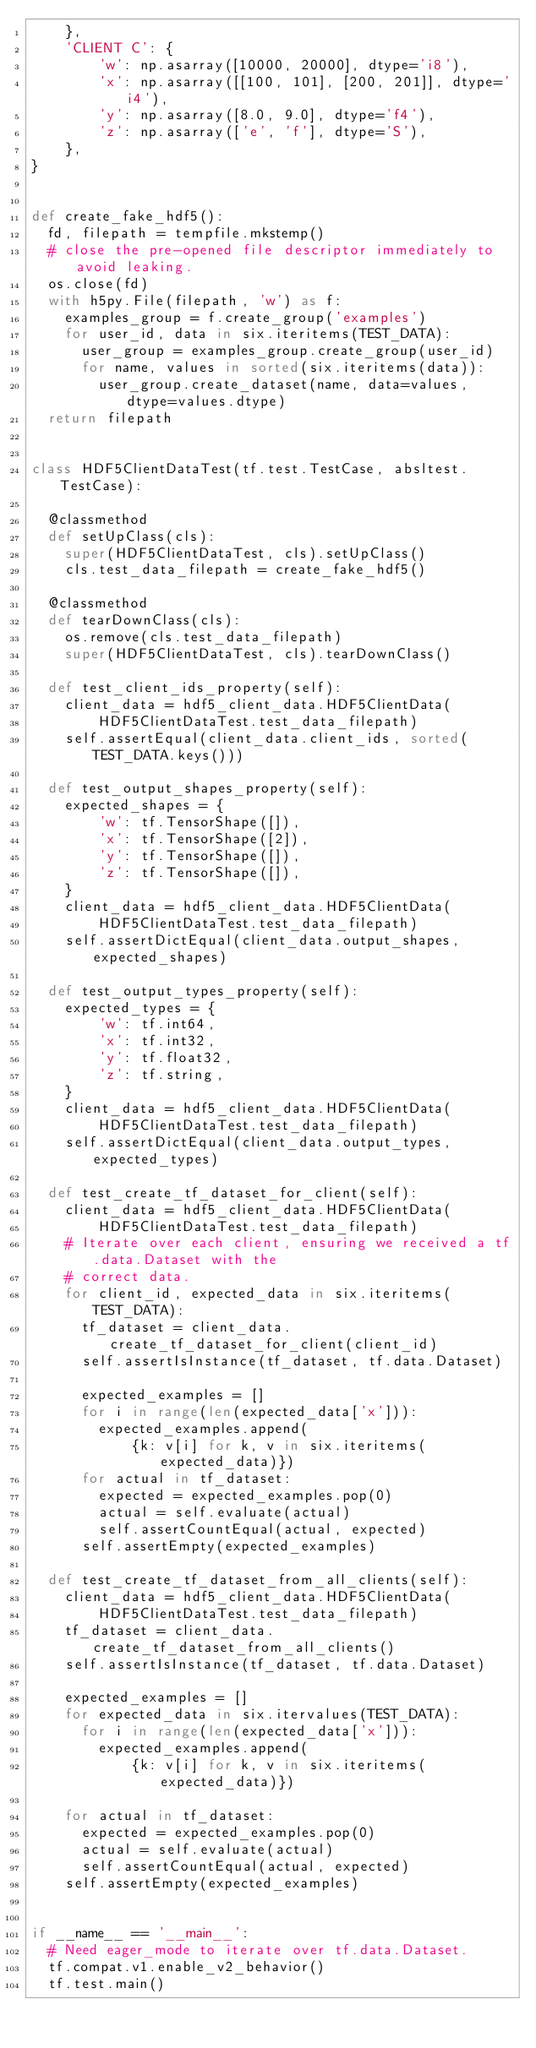<code> <loc_0><loc_0><loc_500><loc_500><_Python_>    },
    'CLIENT C': {
        'w': np.asarray([10000, 20000], dtype='i8'),
        'x': np.asarray([[100, 101], [200, 201]], dtype='i4'),
        'y': np.asarray([8.0, 9.0], dtype='f4'),
        'z': np.asarray(['e', 'f'], dtype='S'),
    },
}


def create_fake_hdf5():
  fd, filepath = tempfile.mkstemp()
  # close the pre-opened file descriptor immediately to avoid leaking.
  os.close(fd)
  with h5py.File(filepath, 'w') as f:
    examples_group = f.create_group('examples')
    for user_id, data in six.iteritems(TEST_DATA):
      user_group = examples_group.create_group(user_id)
      for name, values in sorted(six.iteritems(data)):
        user_group.create_dataset(name, data=values, dtype=values.dtype)
  return filepath


class HDF5ClientDataTest(tf.test.TestCase, absltest.TestCase):

  @classmethod
  def setUpClass(cls):
    super(HDF5ClientDataTest, cls).setUpClass()
    cls.test_data_filepath = create_fake_hdf5()

  @classmethod
  def tearDownClass(cls):
    os.remove(cls.test_data_filepath)
    super(HDF5ClientDataTest, cls).tearDownClass()

  def test_client_ids_property(self):
    client_data = hdf5_client_data.HDF5ClientData(
        HDF5ClientDataTest.test_data_filepath)
    self.assertEqual(client_data.client_ids, sorted(TEST_DATA.keys()))

  def test_output_shapes_property(self):
    expected_shapes = {
        'w': tf.TensorShape([]),
        'x': tf.TensorShape([2]),
        'y': tf.TensorShape([]),
        'z': tf.TensorShape([]),
    }
    client_data = hdf5_client_data.HDF5ClientData(
        HDF5ClientDataTest.test_data_filepath)
    self.assertDictEqual(client_data.output_shapes, expected_shapes)

  def test_output_types_property(self):
    expected_types = {
        'w': tf.int64,
        'x': tf.int32,
        'y': tf.float32,
        'z': tf.string,
    }
    client_data = hdf5_client_data.HDF5ClientData(
        HDF5ClientDataTest.test_data_filepath)
    self.assertDictEqual(client_data.output_types, expected_types)

  def test_create_tf_dataset_for_client(self):
    client_data = hdf5_client_data.HDF5ClientData(
        HDF5ClientDataTest.test_data_filepath)
    # Iterate over each client, ensuring we received a tf.data.Dataset with the
    # correct data.
    for client_id, expected_data in six.iteritems(TEST_DATA):
      tf_dataset = client_data.create_tf_dataset_for_client(client_id)
      self.assertIsInstance(tf_dataset, tf.data.Dataset)

      expected_examples = []
      for i in range(len(expected_data['x'])):
        expected_examples.append(
            {k: v[i] for k, v in six.iteritems(expected_data)})
      for actual in tf_dataset:
        expected = expected_examples.pop(0)
        actual = self.evaluate(actual)
        self.assertCountEqual(actual, expected)
      self.assertEmpty(expected_examples)

  def test_create_tf_dataset_from_all_clients(self):
    client_data = hdf5_client_data.HDF5ClientData(
        HDF5ClientDataTest.test_data_filepath)
    tf_dataset = client_data.create_tf_dataset_from_all_clients()
    self.assertIsInstance(tf_dataset, tf.data.Dataset)

    expected_examples = []
    for expected_data in six.itervalues(TEST_DATA):
      for i in range(len(expected_data['x'])):
        expected_examples.append(
            {k: v[i] for k, v in six.iteritems(expected_data)})

    for actual in tf_dataset:
      expected = expected_examples.pop(0)
      actual = self.evaluate(actual)
      self.assertCountEqual(actual, expected)
    self.assertEmpty(expected_examples)


if __name__ == '__main__':
  # Need eager_mode to iterate over tf.data.Dataset.
  tf.compat.v1.enable_v2_behavior()
  tf.test.main()
</code> 